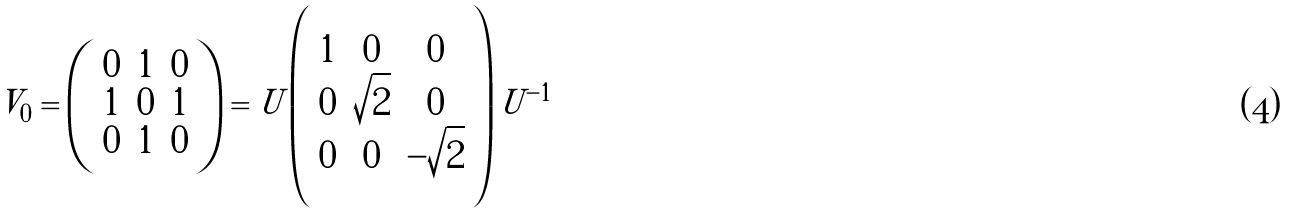Convert formula to latex. <formula><loc_0><loc_0><loc_500><loc_500>V _ { 0 } = \left ( \begin{array} { c c c } 0 & 1 & 0 \\ 1 & 0 & 1 \\ 0 & 1 & 0 \end{array} \right ) = U \left ( \begin{array} { c c c } 1 & 0 & 0 \\ 0 & \sqrt { 2 } & 0 \\ 0 & 0 & - \sqrt { 2 } \end{array} \right ) U ^ { - 1 }</formula> 